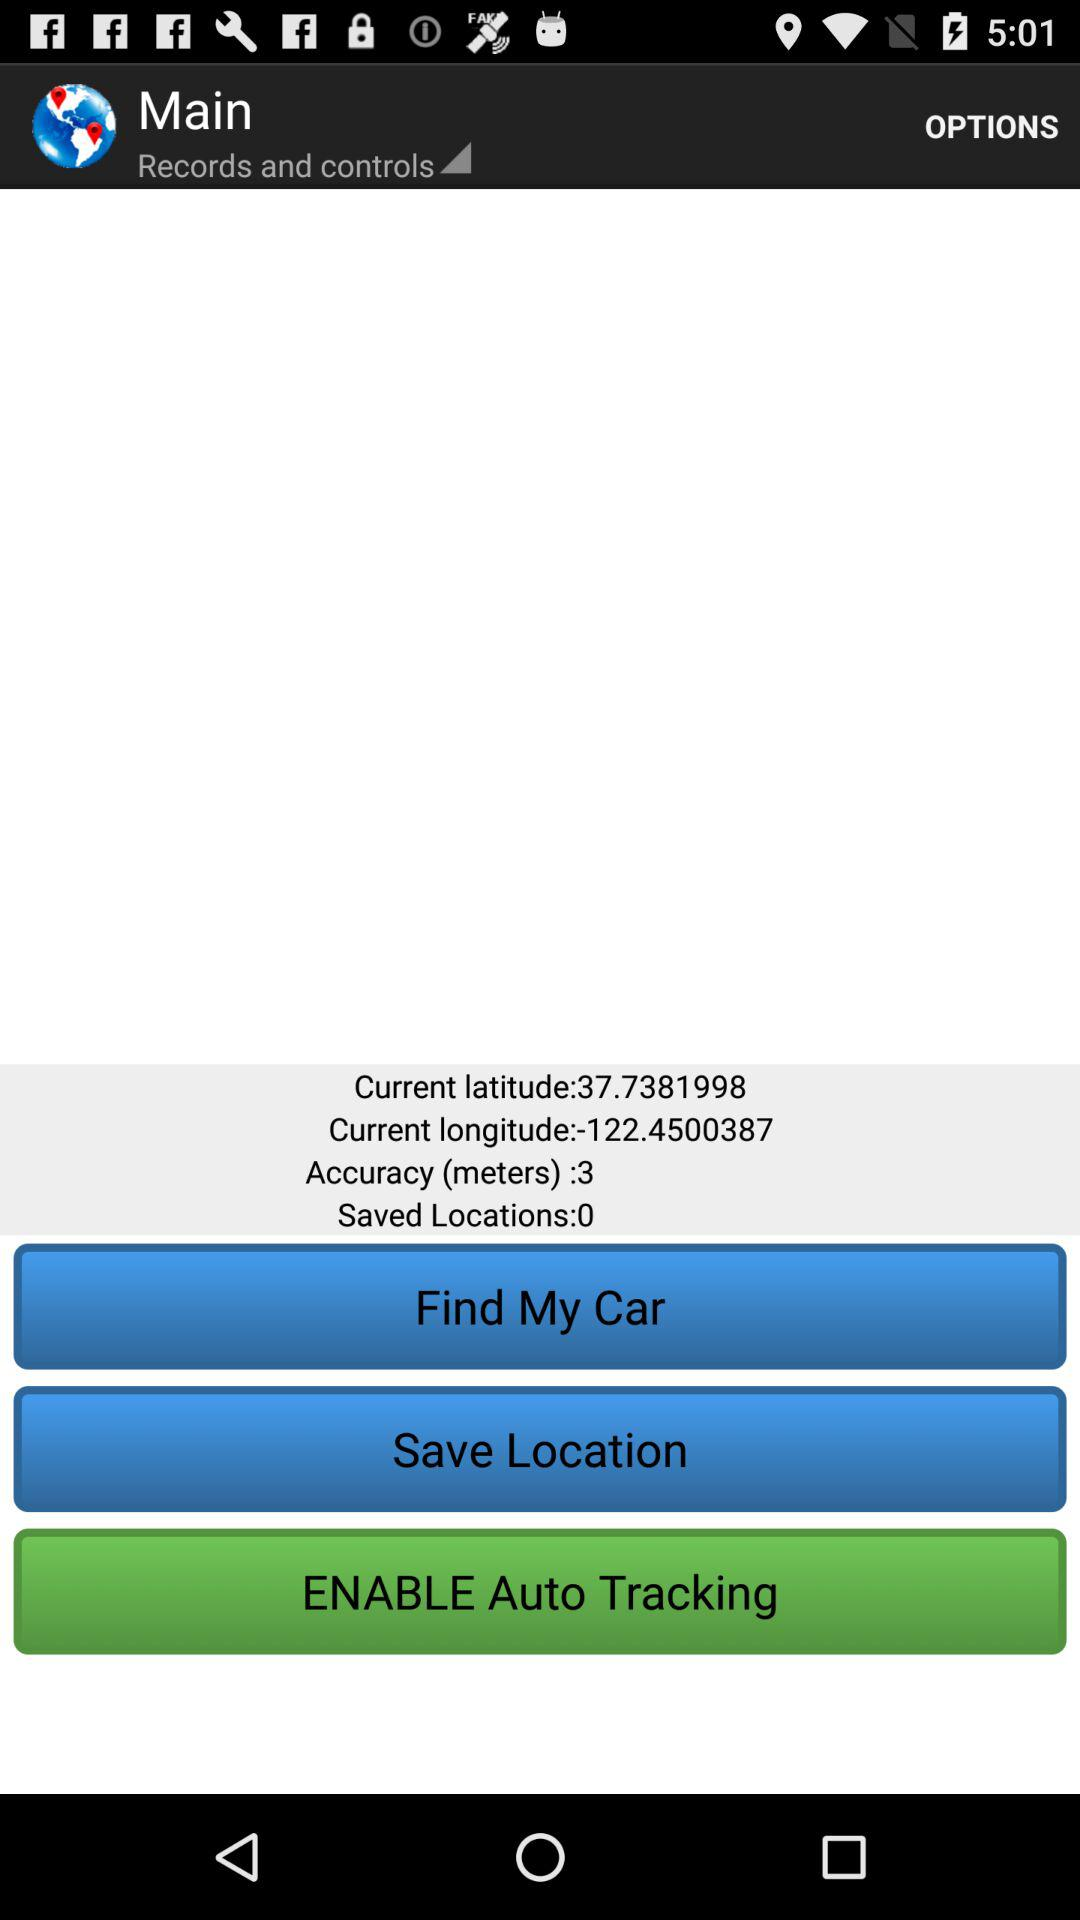What is the current latitude? The current latitude is 37.7381998. 